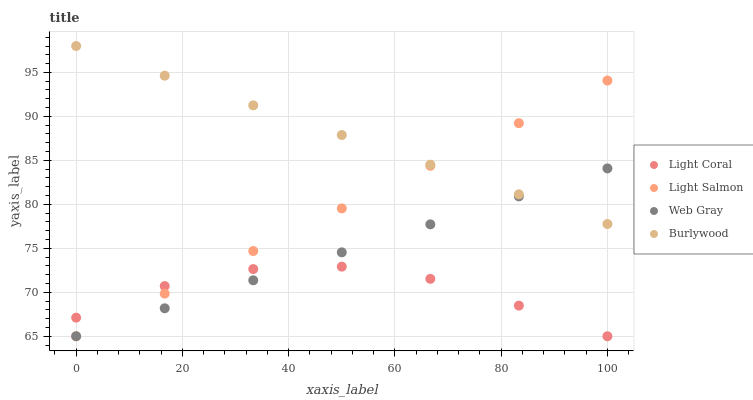Does Light Coral have the minimum area under the curve?
Answer yes or no. Yes. Does Burlywood have the maximum area under the curve?
Answer yes or no. Yes. Does Light Salmon have the minimum area under the curve?
Answer yes or no. No. Does Light Salmon have the maximum area under the curve?
Answer yes or no. No. Is Burlywood the smoothest?
Answer yes or no. Yes. Is Light Coral the roughest?
Answer yes or no. Yes. Is Light Salmon the smoothest?
Answer yes or no. No. Is Light Salmon the roughest?
Answer yes or no. No. Does Light Coral have the lowest value?
Answer yes or no. Yes. Does Burlywood have the lowest value?
Answer yes or no. No. Does Burlywood have the highest value?
Answer yes or no. Yes. Does Light Salmon have the highest value?
Answer yes or no. No. Is Light Coral less than Burlywood?
Answer yes or no. Yes. Is Burlywood greater than Light Coral?
Answer yes or no. Yes. Does Light Coral intersect Light Salmon?
Answer yes or no. Yes. Is Light Coral less than Light Salmon?
Answer yes or no. No. Is Light Coral greater than Light Salmon?
Answer yes or no. No. Does Light Coral intersect Burlywood?
Answer yes or no. No. 